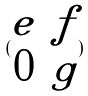<formula> <loc_0><loc_0><loc_500><loc_500>( \begin{matrix} e & f \\ 0 & g \end{matrix} )</formula> 